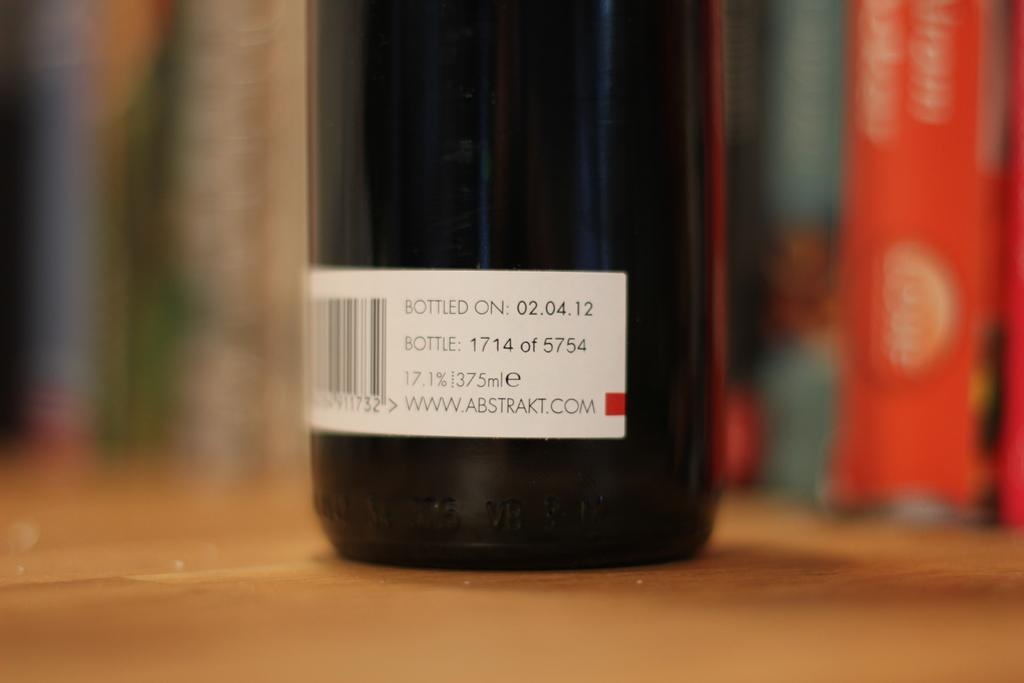What object is placed on the table in the image? There is a bottle on the table in the image. What is on the bottle? There is a sticker on the bottle. What can be seen in the background of the image? Books are visible in the background of the image. How would you describe the quality of the image? The image is blurry. What emotion does the bottle appear to be feeling in the image? Bottles do not have emotions, so it is not possible to determine how the bottle might be feeling. 